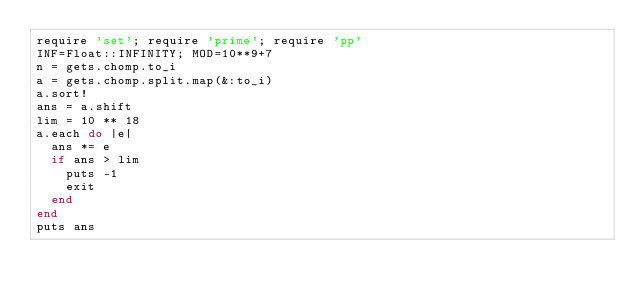Convert code to text. <code><loc_0><loc_0><loc_500><loc_500><_Ruby_>require 'set'; require 'prime'; require 'pp'
INF=Float::INFINITY; MOD=10**9+7
n = gets.chomp.to_i
a = gets.chomp.split.map(&:to_i)
a.sort!
ans = a.shift
lim = 10 ** 18
a.each do |e|
  ans *= e
  if ans > lim
    puts -1
    exit
  end
end
puts ans
</code> 